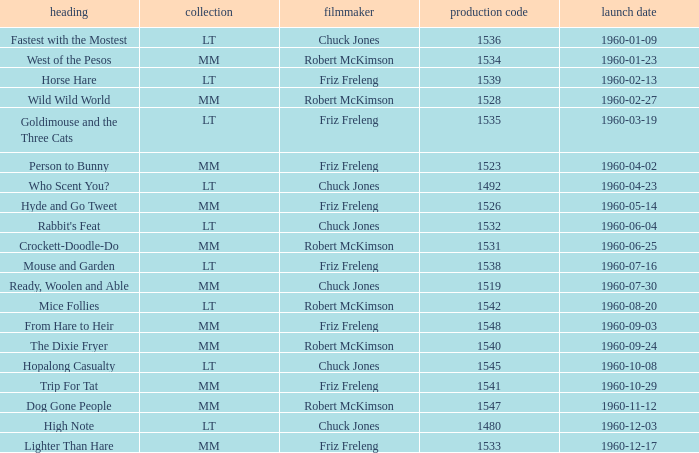What is the production number of From Hare to Heir? 1548.0. 